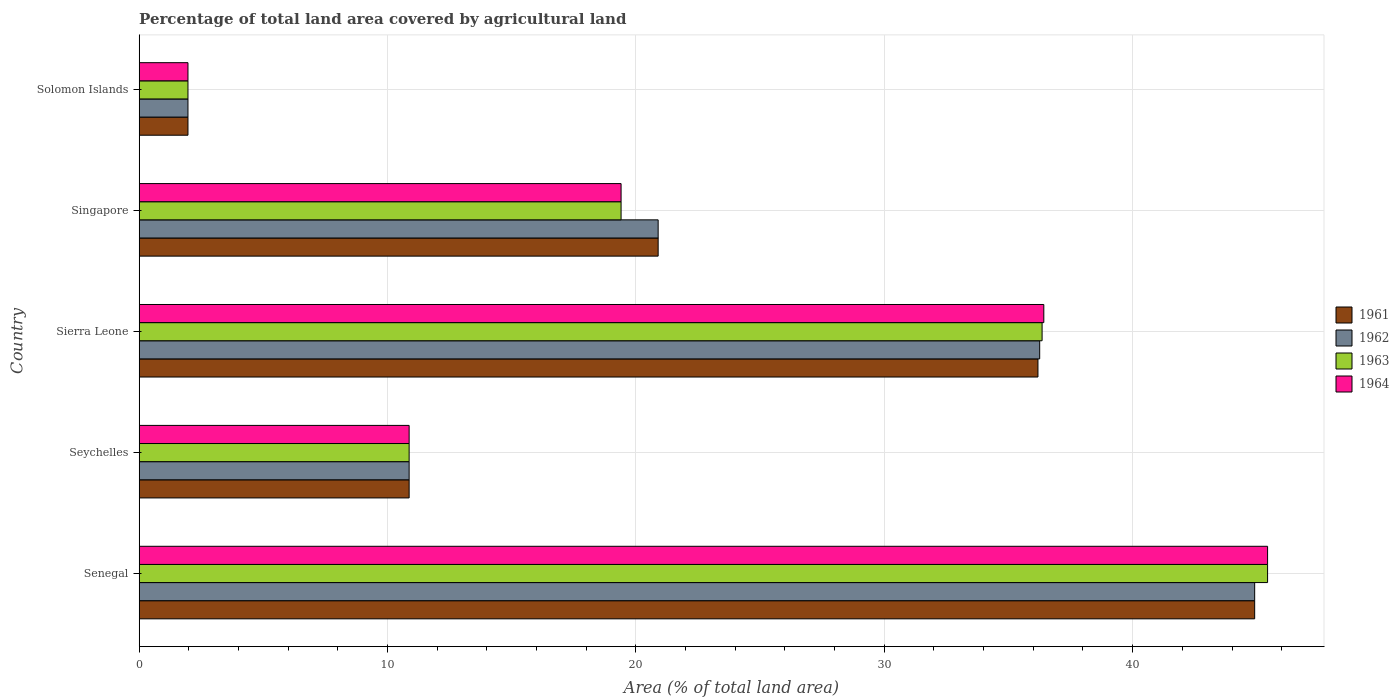How many different coloured bars are there?
Ensure brevity in your answer.  4. Are the number of bars per tick equal to the number of legend labels?
Your response must be concise. Yes. Are the number of bars on each tick of the Y-axis equal?
Your response must be concise. Yes. How many bars are there on the 3rd tick from the top?
Offer a terse response. 4. How many bars are there on the 2nd tick from the bottom?
Offer a very short reply. 4. What is the label of the 2nd group of bars from the top?
Give a very brief answer. Singapore. In how many cases, is the number of bars for a given country not equal to the number of legend labels?
Keep it short and to the point. 0. What is the percentage of agricultural land in 1964 in Solomon Islands?
Ensure brevity in your answer.  1.96. Across all countries, what is the maximum percentage of agricultural land in 1962?
Your answer should be very brief. 44.91. Across all countries, what is the minimum percentage of agricultural land in 1961?
Keep it short and to the point. 1.96. In which country was the percentage of agricultural land in 1961 maximum?
Keep it short and to the point. Senegal. In which country was the percentage of agricultural land in 1961 minimum?
Your answer should be very brief. Solomon Islands. What is the total percentage of agricultural land in 1963 in the graph?
Provide a short and direct response. 114.02. What is the difference between the percentage of agricultural land in 1961 in Seychelles and that in Singapore?
Your answer should be very brief. -10.03. What is the difference between the percentage of agricultural land in 1963 in Sierra Leone and the percentage of agricultural land in 1964 in Seychelles?
Offer a terse response. 25.48. What is the average percentage of agricultural land in 1963 per country?
Provide a succinct answer. 22.8. What is the difference between the percentage of agricultural land in 1961 and percentage of agricultural land in 1963 in Sierra Leone?
Keep it short and to the point. -0.17. In how many countries, is the percentage of agricultural land in 1962 greater than 44 %?
Offer a terse response. 1. What is the ratio of the percentage of agricultural land in 1962 in Seychelles to that in Sierra Leone?
Your answer should be compact. 0.3. Is the difference between the percentage of agricultural land in 1961 in Seychelles and Solomon Islands greater than the difference between the percentage of agricultural land in 1963 in Seychelles and Solomon Islands?
Ensure brevity in your answer.  No. What is the difference between the highest and the second highest percentage of agricultural land in 1961?
Your answer should be very brief. 8.73. What is the difference between the highest and the lowest percentage of agricultural land in 1963?
Provide a short and direct response. 43.47. In how many countries, is the percentage of agricultural land in 1961 greater than the average percentage of agricultural land in 1961 taken over all countries?
Keep it short and to the point. 2. What does the 1st bar from the top in Solomon Islands represents?
Provide a succinct answer. 1964. What does the 2nd bar from the bottom in Seychelles represents?
Your response must be concise. 1962. Is it the case that in every country, the sum of the percentage of agricultural land in 1963 and percentage of agricultural land in 1964 is greater than the percentage of agricultural land in 1962?
Offer a terse response. Yes. Does the graph contain any zero values?
Offer a very short reply. No. Does the graph contain grids?
Keep it short and to the point. Yes. How many legend labels are there?
Provide a succinct answer. 4. How are the legend labels stacked?
Offer a terse response. Vertical. What is the title of the graph?
Your response must be concise. Percentage of total land area covered by agricultural land. Does "1967" appear as one of the legend labels in the graph?
Your answer should be very brief. No. What is the label or title of the X-axis?
Your answer should be very brief. Area (% of total land area). What is the Area (% of total land area) of 1961 in Senegal?
Provide a succinct answer. 44.91. What is the Area (% of total land area) of 1962 in Senegal?
Give a very brief answer. 44.91. What is the Area (% of total land area) in 1963 in Senegal?
Your answer should be very brief. 45.43. What is the Area (% of total land area) in 1964 in Senegal?
Make the answer very short. 45.43. What is the Area (% of total land area) of 1961 in Seychelles?
Your response must be concise. 10.87. What is the Area (% of total land area) of 1962 in Seychelles?
Give a very brief answer. 10.87. What is the Area (% of total land area) of 1963 in Seychelles?
Offer a very short reply. 10.87. What is the Area (% of total land area) of 1964 in Seychelles?
Offer a very short reply. 10.87. What is the Area (% of total land area) of 1961 in Sierra Leone?
Give a very brief answer. 36.19. What is the Area (% of total land area) of 1962 in Sierra Leone?
Your answer should be very brief. 36.26. What is the Area (% of total land area) in 1963 in Sierra Leone?
Ensure brevity in your answer.  36.35. What is the Area (% of total land area) in 1964 in Sierra Leone?
Provide a succinct answer. 36.42. What is the Area (% of total land area) in 1961 in Singapore?
Provide a succinct answer. 20.9. What is the Area (% of total land area) of 1962 in Singapore?
Make the answer very short. 20.9. What is the Area (% of total land area) of 1963 in Singapore?
Provide a succinct answer. 19.4. What is the Area (% of total land area) of 1964 in Singapore?
Give a very brief answer. 19.4. What is the Area (% of total land area) of 1961 in Solomon Islands?
Your answer should be very brief. 1.96. What is the Area (% of total land area) in 1962 in Solomon Islands?
Provide a short and direct response. 1.96. What is the Area (% of total land area) in 1963 in Solomon Islands?
Offer a terse response. 1.96. What is the Area (% of total land area) of 1964 in Solomon Islands?
Your answer should be compact. 1.96. Across all countries, what is the maximum Area (% of total land area) in 1961?
Provide a succinct answer. 44.91. Across all countries, what is the maximum Area (% of total land area) in 1962?
Give a very brief answer. 44.91. Across all countries, what is the maximum Area (% of total land area) of 1963?
Make the answer very short. 45.43. Across all countries, what is the maximum Area (% of total land area) of 1964?
Make the answer very short. 45.43. Across all countries, what is the minimum Area (% of total land area) of 1961?
Make the answer very short. 1.96. Across all countries, what is the minimum Area (% of total land area) in 1962?
Make the answer very short. 1.96. Across all countries, what is the minimum Area (% of total land area) of 1963?
Offer a terse response. 1.96. Across all countries, what is the minimum Area (% of total land area) in 1964?
Offer a very short reply. 1.96. What is the total Area (% of total land area) in 1961 in the graph?
Your answer should be compact. 114.83. What is the total Area (% of total land area) in 1962 in the graph?
Your answer should be compact. 114.9. What is the total Area (% of total land area) in 1963 in the graph?
Keep it short and to the point. 114.02. What is the total Area (% of total land area) of 1964 in the graph?
Provide a short and direct response. 114.09. What is the difference between the Area (% of total land area) of 1961 in Senegal and that in Seychelles?
Your answer should be very brief. 34.04. What is the difference between the Area (% of total land area) of 1962 in Senegal and that in Seychelles?
Provide a succinct answer. 34.04. What is the difference between the Area (% of total land area) of 1963 in Senegal and that in Seychelles?
Provide a succinct answer. 34.56. What is the difference between the Area (% of total land area) in 1964 in Senegal and that in Seychelles?
Your answer should be compact. 34.56. What is the difference between the Area (% of total land area) in 1961 in Senegal and that in Sierra Leone?
Make the answer very short. 8.73. What is the difference between the Area (% of total land area) of 1962 in Senegal and that in Sierra Leone?
Provide a short and direct response. 8.66. What is the difference between the Area (% of total land area) in 1963 in Senegal and that in Sierra Leone?
Provide a succinct answer. 9.08. What is the difference between the Area (% of total land area) of 1964 in Senegal and that in Sierra Leone?
Keep it short and to the point. 9.01. What is the difference between the Area (% of total land area) of 1961 in Senegal and that in Singapore?
Give a very brief answer. 24.02. What is the difference between the Area (% of total land area) of 1962 in Senegal and that in Singapore?
Offer a terse response. 24.02. What is the difference between the Area (% of total land area) of 1963 in Senegal and that in Singapore?
Ensure brevity in your answer.  26.03. What is the difference between the Area (% of total land area) of 1964 in Senegal and that in Singapore?
Keep it short and to the point. 26.03. What is the difference between the Area (% of total land area) in 1961 in Senegal and that in Solomon Islands?
Your response must be concise. 42.95. What is the difference between the Area (% of total land area) in 1962 in Senegal and that in Solomon Islands?
Offer a very short reply. 42.95. What is the difference between the Area (% of total land area) of 1963 in Senegal and that in Solomon Islands?
Give a very brief answer. 43.47. What is the difference between the Area (% of total land area) in 1964 in Senegal and that in Solomon Islands?
Offer a very short reply. 43.47. What is the difference between the Area (% of total land area) in 1961 in Seychelles and that in Sierra Leone?
Provide a short and direct response. -25.32. What is the difference between the Area (% of total land area) in 1962 in Seychelles and that in Sierra Leone?
Offer a terse response. -25.39. What is the difference between the Area (% of total land area) of 1963 in Seychelles and that in Sierra Leone?
Offer a very short reply. -25.48. What is the difference between the Area (% of total land area) in 1964 in Seychelles and that in Sierra Leone?
Offer a terse response. -25.55. What is the difference between the Area (% of total land area) of 1961 in Seychelles and that in Singapore?
Keep it short and to the point. -10.03. What is the difference between the Area (% of total land area) in 1962 in Seychelles and that in Singapore?
Give a very brief answer. -10.03. What is the difference between the Area (% of total land area) in 1963 in Seychelles and that in Singapore?
Your answer should be compact. -8.53. What is the difference between the Area (% of total land area) in 1964 in Seychelles and that in Singapore?
Keep it short and to the point. -8.53. What is the difference between the Area (% of total land area) in 1961 in Seychelles and that in Solomon Islands?
Provide a succinct answer. 8.9. What is the difference between the Area (% of total land area) of 1962 in Seychelles and that in Solomon Islands?
Offer a very short reply. 8.9. What is the difference between the Area (% of total land area) of 1963 in Seychelles and that in Solomon Islands?
Provide a succinct answer. 8.9. What is the difference between the Area (% of total land area) in 1964 in Seychelles and that in Solomon Islands?
Give a very brief answer. 8.9. What is the difference between the Area (% of total land area) of 1961 in Sierra Leone and that in Singapore?
Offer a very short reply. 15.29. What is the difference between the Area (% of total land area) in 1962 in Sierra Leone and that in Singapore?
Offer a very short reply. 15.36. What is the difference between the Area (% of total land area) of 1963 in Sierra Leone and that in Singapore?
Make the answer very short. 16.95. What is the difference between the Area (% of total land area) of 1964 in Sierra Leone and that in Singapore?
Make the answer very short. 17.02. What is the difference between the Area (% of total land area) of 1961 in Sierra Leone and that in Solomon Islands?
Offer a very short reply. 34.22. What is the difference between the Area (% of total land area) of 1962 in Sierra Leone and that in Solomon Islands?
Provide a short and direct response. 34.29. What is the difference between the Area (% of total land area) of 1963 in Sierra Leone and that in Solomon Islands?
Your answer should be very brief. 34.39. What is the difference between the Area (% of total land area) in 1964 in Sierra Leone and that in Solomon Islands?
Provide a succinct answer. 34.46. What is the difference between the Area (% of total land area) in 1961 in Singapore and that in Solomon Islands?
Provide a short and direct response. 18.93. What is the difference between the Area (% of total land area) of 1962 in Singapore and that in Solomon Islands?
Your response must be concise. 18.93. What is the difference between the Area (% of total land area) in 1963 in Singapore and that in Solomon Islands?
Make the answer very short. 17.44. What is the difference between the Area (% of total land area) in 1964 in Singapore and that in Solomon Islands?
Ensure brevity in your answer.  17.44. What is the difference between the Area (% of total land area) of 1961 in Senegal and the Area (% of total land area) of 1962 in Seychelles?
Provide a succinct answer. 34.04. What is the difference between the Area (% of total land area) in 1961 in Senegal and the Area (% of total land area) in 1963 in Seychelles?
Offer a very short reply. 34.04. What is the difference between the Area (% of total land area) in 1961 in Senegal and the Area (% of total land area) in 1964 in Seychelles?
Provide a succinct answer. 34.04. What is the difference between the Area (% of total land area) of 1962 in Senegal and the Area (% of total land area) of 1963 in Seychelles?
Offer a very short reply. 34.04. What is the difference between the Area (% of total land area) in 1962 in Senegal and the Area (% of total land area) in 1964 in Seychelles?
Make the answer very short. 34.04. What is the difference between the Area (% of total land area) in 1963 in Senegal and the Area (% of total land area) in 1964 in Seychelles?
Offer a terse response. 34.56. What is the difference between the Area (% of total land area) of 1961 in Senegal and the Area (% of total land area) of 1962 in Sierra Leone?
Make the answer very short. 8.66. What is the difference between the Area (% of total land area) in 1961 in Senegal and the Area (% of total land area) in 1963 in Sierra Leone?
Offer a very short reply. 8.56. What is the difference between the Area (% of total land area) in 1961 in Senegal and the Area (% of total land area) in 1964 in Sierra Leone?
Offer a very short reply. 8.49. What is the difference between the Area (% of total land area) of 1962 in Senegal and the Area (% of total land area) of 1963 in Sierra Leone?
Your response must be concise. 8.56. What is the difference between the Area (% of total land area) in 1962 in Senegal and the Area (% of total land area) in 1964 in Sierra Leone?
Your answer should be very brief. 8.49. What is the difference between the Area (% of total land area) in 1963 in Senegal and the Area (% of total land area) in 1964 in Sierra Leone?
Keep it short and to the point. 9.01. What is the difference between the Area (% of total land area) in 1961 in Senegal and the Area (% of total land area) in 1962 in Singapore?
Keep it short and to the point. 24.02. What is the difference between the Area (% of total land area) of 1961 in Senegal and the Area (% of total land area) of 1963 in Singapore?
Offer a terse response. 25.51. What is the difference between the Area (% of total land area) in 1961 in Senegal and the Area (% of total land area) in 1964 in Singapore?
Make the answer very short. 25.51. What is the difference between the Area (% of total land area) in 1962 in Senegal and the Area (% of total land area) in 1963 in Singapore?
Give a very brief answer. 25.51. What is the difference between the Area (% of total land area) in 1962 in Senegal and the Area (% of total land area) in 1964 in Singapore?
Your answer should be very brief. 25.51. What is the difference between the Area (% of total land area) of 1963 in Senegal and the Area (% of total land area) of 1964 in Singapore?
Make the answer very short. 26.03. What is the difference between the Area (% of total land area) in 1961 in Senegal and the Area (% of total land area) in 1962 in Solomon Islands?
Offer a terse response. 42.95. What is the difference between the Area (% of total land area) in 1961 in Senegal and the Area (% of total land area) in 1963 in Solomon Islands?
Your response must be concise. 42.95. What is the difference between the Area (% of total land area) in 1961 in Senegal and the Area (% of total land area) in 1964 in Solomon Islands?
Give a very brief answer. 42.95. What is the difference between the Area (% of total land area) in 1962 in Senegal and the Area (% of total land area) in 1963 in Solomon Islands?
Make the answer very short. 42.95. What is the difference between the Area (% of total land area) of 1962 in Senegal and the Area (% of total land area) of 1964 in Solomon Islands?
Your answer should be very brief. 42.95. What is the difference between the Area (% of total land area) of 1963 in Senegal and the Area (% of total land area) of 1964 in Solomon Islands?
Ensure brevity in your answer.  43.47. What is the difference between the Area (% of total land area) of 1961 in Seychelles and the Area (% of total land area) of 1962 in Sierra Leone?
Offer a very short reply. -25.39. What is the difference between the Area (% of total land area) in 1961 in Seychelles and the Area (% of total land area) in 1963 in Sierra Leone?
Your answer should be compact. -25.48. What is the difference between the Area (% of total land area) in 1961 in Seychelles and the Area (% of total land area) in 1964 in Sierra Leone?
Offer a terse response. -25.55. What is the difference between the Area (% of total land area) of 1962 in Seychelles and the Area (% of total land area) of 1963 in Sierra Leone?
Provide a short and direct response. -25.48. What is the difference between the Area (% of total land area) of 1962 in Seychelles and the Area (% of total land area) of 1964 in Sierra Leone?
Give a very brief answer. -25.55. What is the difference between the Area (% of total land area) in 1963 in Seychelles and the Area (% of total land area) in 1964 in Sierra Leone?
Your response must be concise. -25.55. What is the difference between the Area (% of total land area) in 1961 in Seychelles and the Area (% of total land area) in 1962 in Singapore?
Provide a succinct answer. -10.03. What is the difference between the Area (% of total land area) of 1961 in Seychelles and the Area (% of total land area) of 1963 in Singapore?
Give a very brief answer. -8.53. What is the difference between the Area (% of total land area) of 1961 in Seychelles and the Area (% of total land area) of 1964 in Singapore?
Your answer should be compact. -8.53. What is the difference between the Area (% of total land area) of 1962 in Seychelles and the Area (% of total land area) of 1963 in Singapore?
Give a very brief answer. -8.53. What is the difference between the Area (% of total land area) of 1962 in Seychelles and the Area (% of total land area) of 1964 in Singapore?
Give a very brief answer. -8.53. What is the difference between the Area (% of total land area) in 1963 in Seychelles and the Area (% of total land area) in 1964 in Singapore?
Your response must be concise. -8.53. What is the difference between the Area (% of total land area) of 1961 in Seychelles and the Area (% of total land area) of 1962 in Solomon Islands?
Offer a very short reply. 8.9. What is the difference between the Area (% of total land area) of 1961 in Seychelles and the Area (% of total land area) of 1963 in Solomon Islands?
Offer a terse response. 8.9. What is the difference between the Area (% of total land area) in 1961 in Seychelles and the Area (% of total land area) in 1964 in Solomon Islands?
Give a very brief answer. 8.9. What is the difference between the Area (% of total land area) of 1962 in Seychelles and the Area (% of total land area) of 1963 in Solomon Islands?
Give a very brief answer. 8.9. What is the difference between the Area (% of total land area) in 1962 in Seychelles and the Area (% of total land area) in 1964 in Solomon Islands?
Keep it short and to the point. 8.9. What is the difference between the Area (% of total land area) in 1963 in Seychelles and the Area (% of total land area) in 1964 in Solomon Islands?
Make the answer very short. 8.9. What is the difference between the Area (% of total land area) of 1961 in Sierra Leone and the Area (% of total land area) of 1962 in Singapore?
Your answer should be very brief. 15.29. What is the difference between the Area (% of total land area) of 1961 in Sierra Leone and the Area (% of total land area) of 1963 in Singapore?
Offer a very short reply. 16.78. What is the difference between the Area (% of total land area) of 1961 in Sierra Leone and the Area (% of total land area) of 1964 in Singapore?
Your answer should be very brief. 16.78. What is the difference between the Area (% of total land area) in 1962 in Sierra Leone and the Area (% of total land area) in 1963 in Singapore?
Provide a succinct answer. 16.85. What is the difference between the Area (% of total land area) in 1962 in Sierra Leone and the Area (% of total land area) in 1964 in Singapore?
Your answer should be very brief. 16.85. What is the difference between the Area (% of total land area) of 1963 in Sierra Leone and the Area (% of total land area) of 1964 in Singapore?
Offer a terse response. 16.95. What is the difference between the Area (% of total land area) in 1961 in Sierra Leone and the Area (% of total land area) in 1962 in Solomon Islands?
Offer a very short reply. 34.22. What is the difference between the Area (% of total land area) of 1961 in Sierra Leone and the Area (% of total land area) of 1963 in Solomon Islands?
Provide a short and direct response. 34.22. What is the difference between the Area (% of total land area) in 1961 in Sierra Leone and the Area (% of total land area) in 1964 in Solomon Islands?
Give a very brief answer. 34.22. What is the difference between the Area (% of total land area) of 1962 in Sierra Leone and the Area (% of total land area) of 1963 in Solomon Islands?
Offer a terse response. 34.29. What is the difference between the Area (% of total land area) of 1962 in Sierra Leone and the Area (% of total land area) of 1964 in Solomon Islands?
Offer a very short reply. 34.29. What is the difference between the Area (% of total land area) of 1963 in Sierra Leone and the Area (% of total land area) of 1964 in Solomon Islands?
Your answer should be very brief. 34.39. What is the difference between the Area (% of total land area) in 1961 in Singapore and the Area (% of total land area) in 1962 in Solomon Islands?
Ensure brevity in your answer.  18.93. What is the difference between the Area (% of total land area) of 1961 in Singapore and the Area (% of total land area) of 1963 in Solomon Islands?
Ensure brevity in your answer.  18.93. What is the difference between the Area (% of total land area) in 1961 in Singapore and the Area (% of total land area) in 1964 in Solomon Islands?
Your answer should be compact. 18.93. What is the difference between the Area (% of total land area) in 1962 in Singapore and the Area (% of total land area) in 1963 in Solomon Islands?
Provide a short and direct response. 18.93. What is the difference between the Area (% of total land area) of 1962 in Singapore and the Area (% of total land area) of 1964 in Solomon Islands?
Offer a terse response. 18.93. What is the difference between the Area (% of total land area) of 1963 in Singapore and the Area (% of total land area) of 1964 in Solomon Islands?
Offer a terse response. 17.44. What is the average Area (% of total land area) in 1961 per country?
Offer a very short reply. 22.97. What is the average Area (% of total land area) in 1962 per country?
Make the answer very short. 22.98. What is the average Area (% of total land area) in 1963 per country?
Provide a short and direct response. 22.8. What is the average Area (% of total land area) of 1964 per country?
Keep it short and to the point. 22.82. What is the difference between the Area (% of total land area) in 1961 and Area (% of total land area) in 1962 in Senegal?
Offer a very short reply. 0. What is the difference between the Area (% of total land area) in 1961 and Area (% of total land area) in 1963 in Senegal?
Ensure brevity in your answer.  -0.52. What is the difference between the Area (% of total land area) of 1961 and Area (% of total land area) of 1964 in Senegal?
Make the answer very short. -0.52. What is the difference between the Area (% of total land area) of 1962 and Area (% of total land area) of 1963 in Senegal?
Your answer should be very brief. -0.52. What is the difference between the Area (% of total land area) of 1962 and Area (% of total land area) of 1964 in Senegal?
Provide a succinct answer. -0.52. What is the difference between the Area (% of total land area) in 1961 and Area (% of total land area) in 1962 in Seychelles?
Make the answer very short. 0. What is the difference between the Area (% of total land area) in 1961 and Area (% of total land area) in 1963 in Seychelles?
Make the answer very short. 0. What is the difference between the Area (% of total land area) in 1962 and Area (% of total land area) in 1964 in Seychelles?
Your response must be concise. 0. What is the difference between the Area (% of total land area) in 1963 and Area (% of total land area) in 1964 in Seychelles?
Offer a terse response. 0. What is the difference between the Area (% of total land area) in 1961 and Area (% of total land area) in 1962 in Sierra Leone?
Provide a succinct answer. -0.07. What is the difference between the Area (% of total land area) of 1961 and Area (% of total land area) of 1963 in Sierra Leone?
Give a very brief answer. -0.17. What is the difference between the Area (% of total land area) of 1961 and Area (% of total land area) of 1964 in Sierra Leone?
Your answer should be very brief. -0.24. What is the difference between the Area (% of total land area) of 1962 and Area (% of total land area) of 1963 in Sierra Leone?
Provide a short and direct response. -0.1. What is the difference between the Area (% of total land area) of 1962 and Area (% of total land area) of 1964 in Sierra Leone?
Ensure brevity in your answer.  -0.17. What is the difference between the Area (% of total land area) of 1963 and Area (% of total land area) of 1964 in Sierra Leone?
Keep it short and to the point. -0.07. What is the difference between the Area (% of total land area) of 1961 and Area (% of total land area) of 1963 in Singapore?
Make the answer very short. 1.49. What is the difference between the Area (% of total land area) of 1961 and Area (% of total land area) of 1964 in Singapore?
Offer a very short reply. 1.49. What is the difference between the Area (% of total land area) of 1962 and Area (% of total land area) of 1963 in Singapore?
Provide a succinct answer. 1.49. What is the difference between the Area (% of total land area) of 1962 and Area (% of total land area) of 1964 in Singapore?
Give a very brief answer. 1.49. What is the difference between the Area (% of total land area) of 1962 and Area (% of total land area) of 1964 in Solomon Islands?
Your answer should be very brief. 0. What is the ratio of the Area (% of total land area) of 1961 in Senegal to that in Seychelles?
Provide a succinct answer. 4.13. What is the ratio of the Area (% of total land area) of 1962 in Senegal to that in Seychelles?
Give a very brief answer. 4.13. What is the ratio of the Area (% of total land area) in 1963 in Senegal to that in Seychelles?
Offer a terse response. 4.18. What is the ratio of the Area (% of total land area) in 1964 in Senegal to that in Seychelles?
Provide a short and direct response. 4.18. What is the ratio of the Area (% of total land area) in 1961 in Senegal to that in Sierra Leone?
Offer a terse response. 1.24. What is the ratio of the Area (% of total land area) in 1962 in Senegal to that in Sierra Leone?
Your answer should be very brief. 1.24. What is the ratio of the Area (% of total land area) of 1963 in Senegal to that in Sierra Leone?
Make the answer very short. 1.25. What is the ratio of the Area (% of total land area) of 1964 in Senegal to that in Sierra Leone?
Your response must be concise. 1.25. What is the ratio of the Area (% of total land area) of 1961 in Senegal to that in Singapore?
Make the answer very short. 2.15. What is the ratio of the Area (% of total land area) in 1962 in Senegal to that in Singapore?
Ensure brevity in your answer.  2.15. What is the ratio of the Area (% of total land area) of 1963 in Senegal to that in Singapore?
Provide a short and direct response. 2.34. What is the ratio of the Area (% of total land area) in 1964 in Senegal to that in Singapore?
Offer a terse response. 2.34. What is the ratio of the Area (% of total land area) in 1961 in Senegal to that in Solomon Islands?
Offer a very short reply. 22.86. What is the ratio of the Area (% of total land area) of 1962 in Senegal to that in Solomon Islands?
Offer a very short reply. 22.86. What is the ratio of the Area (% of total land area) in 1963 in Senegal to that in Solomon Islands?
Offer a terse response. 23.12. What is the ratio of the Area (% of total land area) in 1964 in Senegal to that in Solomon Islands?
Offer a very short reply. 23.12. What is the ratio of the Area (% of total land area) of 1961 in Seychelles to that in Sierra Leone?
Your answer should be compact. 0.3. What is the ratio of the Area (% of total land area) of 1962 in Seychelles to that in Sierra Leone?
Your answer should be compact. 0.3. What is the ratio of the Area (% of total land area) in 1963 in Seychelles to that in Sierra Leone?
Ensure brevity in your answer.  0.3. What is the ratio of the Area (% of total land area) of 1964 in Seychelles to that in Sierra Leone?
Keep it short and to the point. 0.3. What is the ratio of the Area (% of total land area) of 1961 in Seychelles to that in Singapore?
Provide a succinct answer. 0.52. What is the ratio of the Area (% of total land area) in 1962 in Seychelles to that in Singapore?
Ensure brevity in your answer.  0.52. What is the ratio of the Area (% of total land area) of 1963 in Seychelles to that in Singapore?
Keep it short and to the point. 0.56. What is the ratio of the Area (% of total land area) of 1964 in Seychelles to that in Singapore?
Ensure brevity in your answer.  0.56. What is the ratio of the Area (% of total land area) in 1961 in Seychelles to that in Solomon Islands?
Keep it short and to the point. 5.53. What is the ratio of the Area (% of total land area) of 1962 in Seychelles to that in Solomon Islands?
Ensure brevity in your answer.  5.53. What is the ratio of the Area (% of total land area) of 1963 in Seychelles to that in Solomon Islands?
Keep it short and to the point. 5.53. What is the ratio of the Area (% of total land area) of 1964 in Seychelles to that in Solomon Islands?
Keep it short and to the point. 5.53. What is the ratio of the Area (% of total land area) of 1961 in Sierra Leone to that in Singapore?
Your answer should be compact. 1.73. What is the ratio of the Area (% of total land area) of 1962 in Sierra Leone to that in Singapore?
Your answer should be compact. 1.74. What is the ratio of the Area (% of total land area) of 1963 in Sierra Leone to that in Singapore?
Make the answer very short. 1.87. What is the ratio of the Area (% of total land area) of 1964 in Sierra Leone to that in Singapore?
Keep it short and to the point. 1.88. What is the ratio of the Area (% of total land area) of 1961 in Sierra Leone to that in Solomon Islands?
Provide a succinct answer. 18.42. What is the ratio of the Area (% of total land area) of 1962 in Sierra Leone to that in Solomon Islands?
Offer a terse response. 18.45. What is the ratio of the Area (% of total land area) of 1963 in Sierra Leone to that in Solomon Islands?
Your answer should be compact. 18.5. What is the ratio of the Area (% of total land area) in 1964 in Sierra Leone to that in Solomon Islands?
Offer a terse response. 18.54. What is the ratio of the Area (% of total land area) in 1961 in Singapore to that in Solomon Islands?
Your answer should be compact. 10.63. What is the ratio of the Area (% of total land area) in 1962 in Singapore to that in Solomon Islands?
Your answer should be very brief. 10.63. What is the ratio of the Area (% of total land area) of 1963 in Singapore to that in Solomon Islands?
Provide a short and direct response. 9.87. What is the ratio of the Area (% of total land area) in 1964 in Singapore to that in Solomon Islands?
Ensure brevity in your answer.  9.87. What is the difference between the highest and the second highest Area (% of total land area) of 1961?
Provide a succinct answer. 8.73. What is the difference between the highest and the second highest Area (% of total land area) of 1962?
Offer a very short reply. 8.66. What is the difference between the highest and the second highest Area (% of total land area) in 1963?
Your answer should be compact. 9.08. What is the difference between the highest and the second highest Area (% of total land area) of 1964?
Your answer should be compact. 9.01. What is the difference between the highest and the lowest Area (% of total land area) of 1961?
Your answer should be very brief. 42.95. What is the difference between the highest and the lowest Area (% of total land area) in 1962?
Ensure brevity in your answer.  42.95. What is the difference between the highest and the lowest Area (% of total land area) in 1963?
Keep it short and to the point. 43.47. What is the difference between the highest and the lowest Area (% of total land area) in 1964?
Keep it short and to the point. 43.47. 